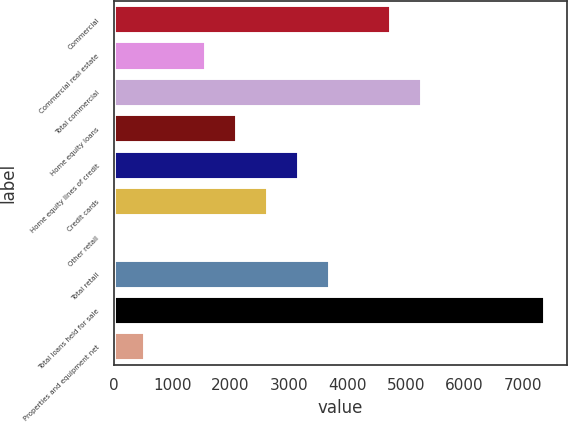Convert chart. <chart><loc_0><loc_0><loc_500><loc_500><bar_chart><fcel>Commercial<fcel>Commercial real estate<fcel>Total commercial<fcel>Home equity loans<fcel>Home equity lines of credit<fcel>Credit cards<fcel>Other retail<fcel>Total retail<fcel>Total loans held for sale<fcel>Properties and equipment net<nl><fcel>4750<fcel>1588<fcel>5277<fcel>2115<fcel>3169<fcel>2642<fcel>7<fcel>3696<fcel>7385<fcel>534<nl></chart> 